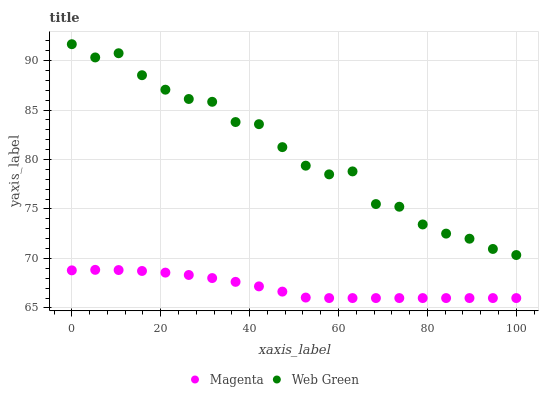Does Magenta have the minimum area under the curve?
Answer yes or no. Yes. Does Web Green have the maximum area under the curve?
Answer yes or no. Yes. Does Web Green have the minimum area under the curve?
Answer yes or no. No. Is Magenta the smoothest?
Answer yes or no. Yes. Is Web Green the roughest?
Answer yes or no. Yes. Is Web Green the smoothest?
Answer yes or no. No. Does Magenta have the lowest value?
Answer yes or no. Yes. Does Web Green have the lowest value?
Answer yes or no. No. Does Web Green have the highest value?
Answer yes or no. Yes. Is Magenta less than Web Green?
Answer yes or no. Yes. Is Web Green greater than Magenta?
Answer yes or no. Yes. Does Magenta intersect Web Green?
Answer yes or no. No. 